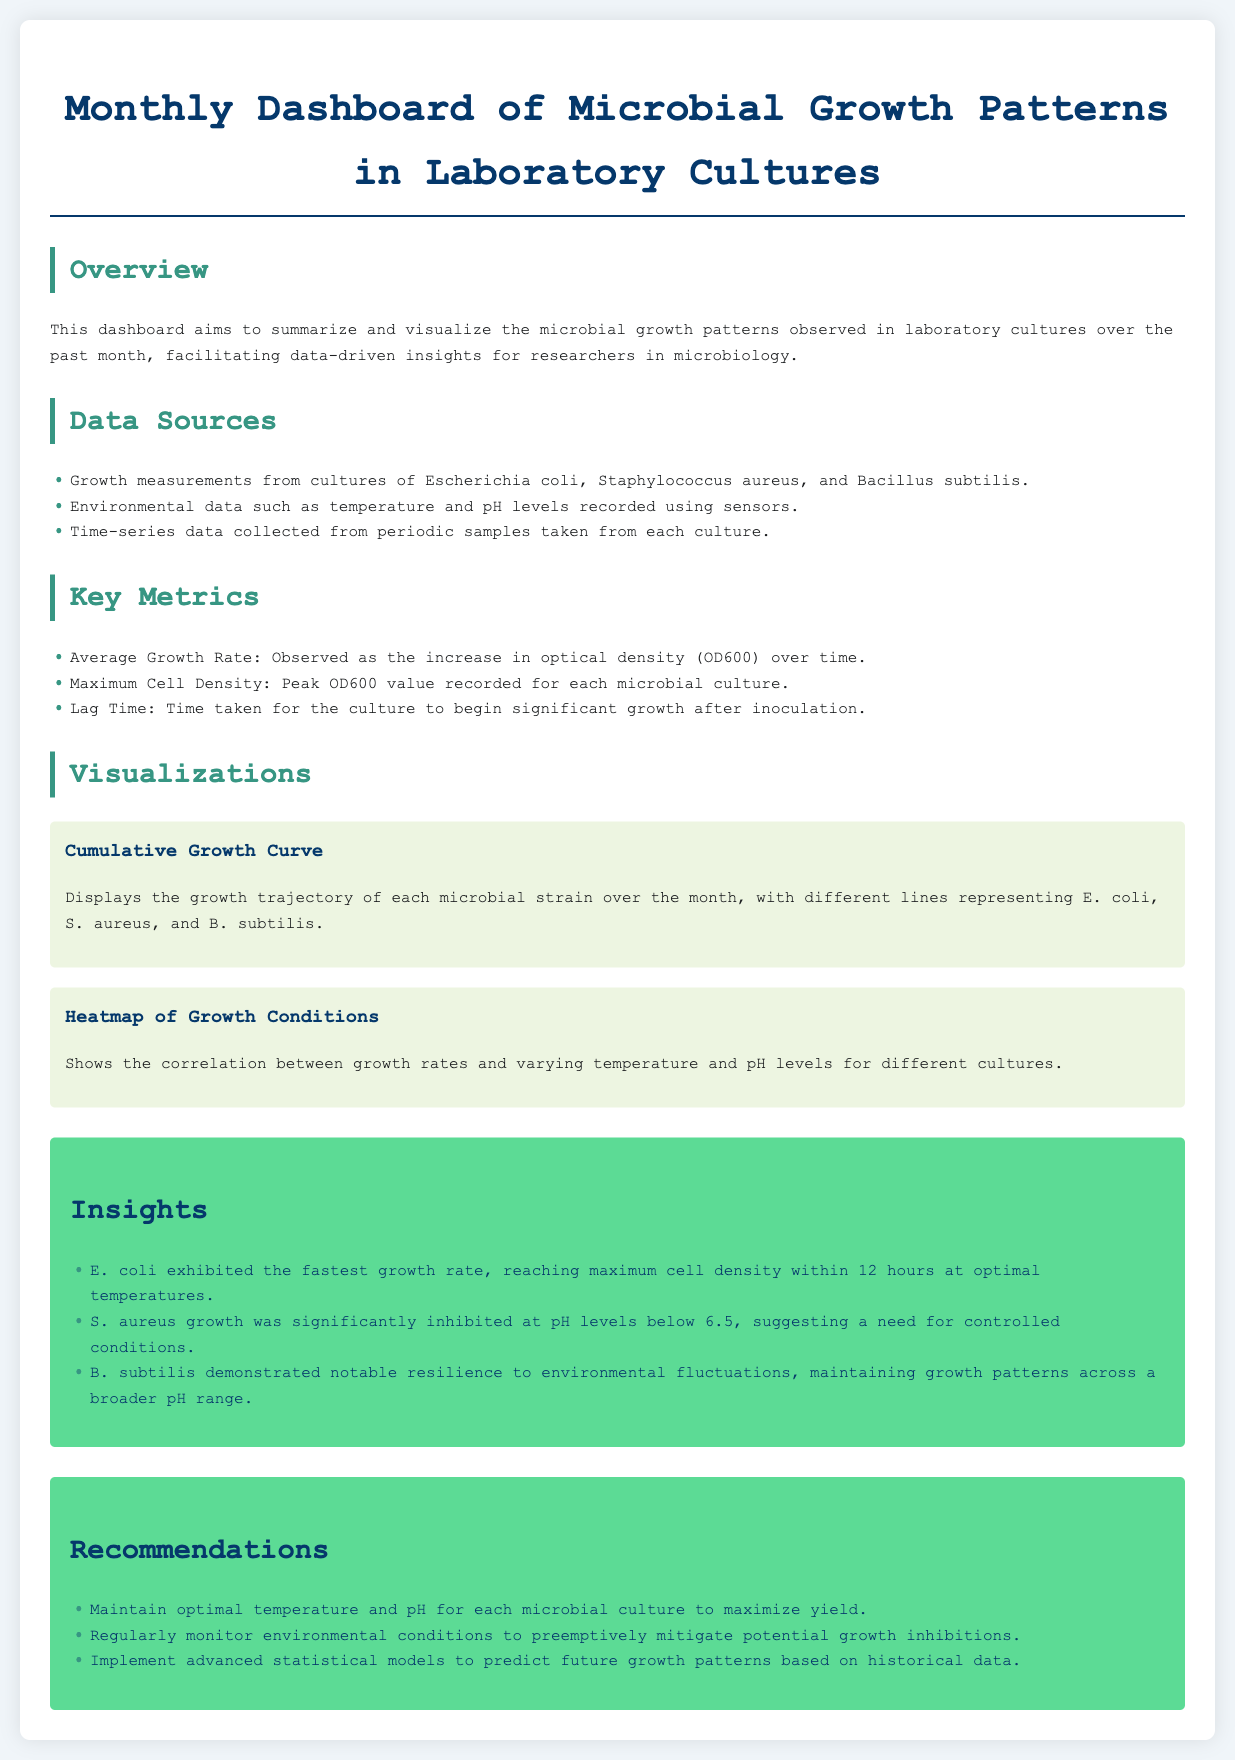What is the title of the document? The title is prominently displayed at the top of the document, summarizing the content.
Answer: Monthly Dashboard of Microbial Growth Patterns in Laboratory Cultures Which three microbial species are included in the data sources? The data sources section lists the specific microbial cultures included in the analysis.
Answer: Escherichia coli, Staphylococcus aureus, Bacillus subtilis What factor significantly inhibited S. aureus growth? The insights section provides specific details on the conditions affecting growth rates for S. aureus.
Answer: pH levels below 6.5 What is the maximum cell density observed for E. coli? The overview section indicates that E. coli reached the maximum cell density at a specified time based on data.
Answer: within 12 hours What are the recommended actions for maintaining optimal microbial culture conditions? The recommendations section outlines specific strategies for improving growth yields in laboratory cultures.
Answer: Maintain optimal temperature and pH What type of visualizations are included in the dashboard? The visualizations section describes the types of charts and graphs present in the document.
Answer: Cumulative Growth Curve, Heatmap of Growth Conditions How is the growth rate measured in this laboratory analysis? The key metrics section defines how growth rates are quantified within the study.
Answer: Increase in optical density (OD600) Which microbial culture demonstrated resilience to environmental fluctuations? The insights section points out which species showed adaptability in growth despite changing conditions.
Answer: B. subtilis 